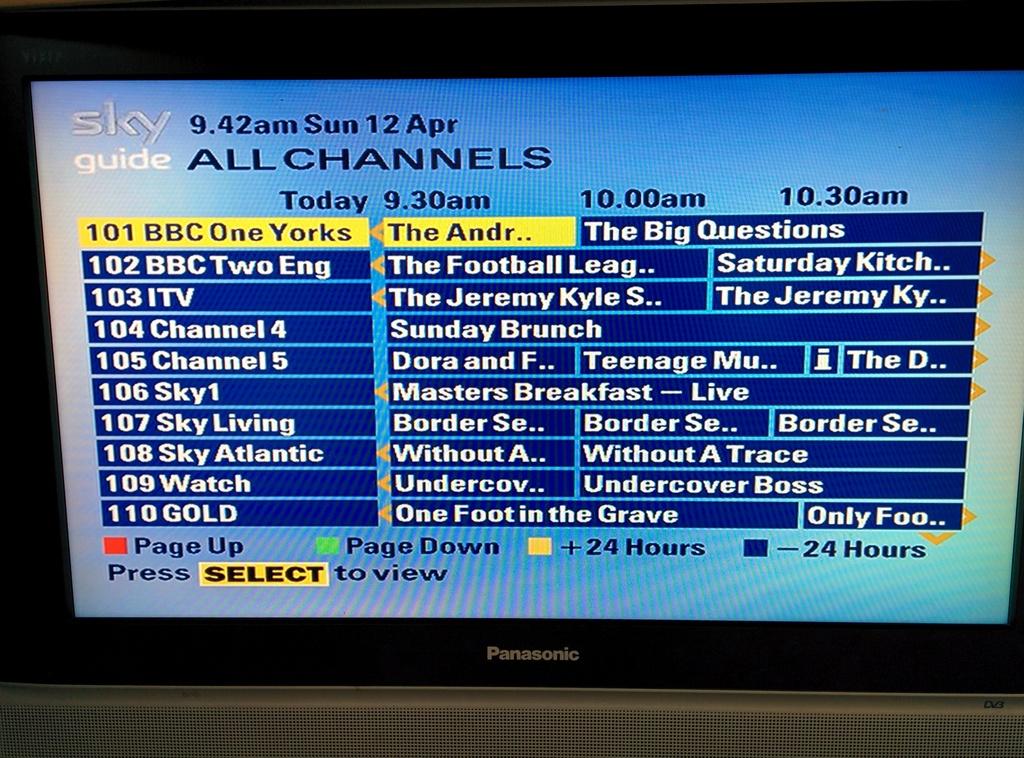What's the date on the screen?
Provide a short and direct response. 12 apr. Who's the tv network for this guide?
Offer a very short reply. Sky. 